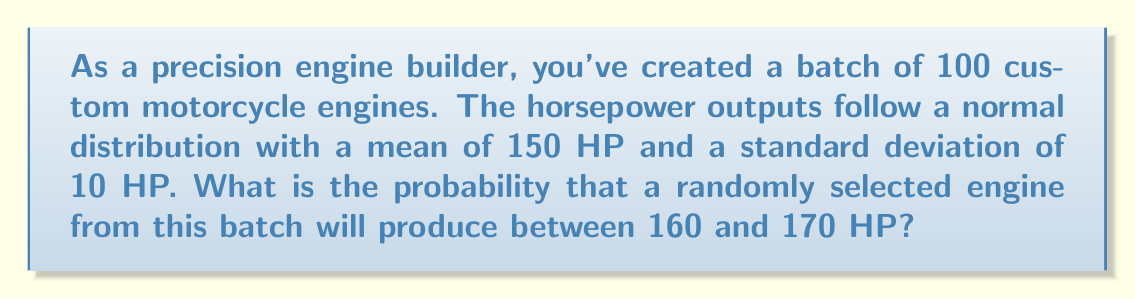Show me your answer to this math problem. To solve this problem, we'll use the properties of the normal distribution and the z-score formula.

Step 1: Identify the given information
- Mean (μ) = 150 HP
- Standard deviation (σ) = 10 HP
- We want the probability of an engine producing between 160 and 170 HP

Step 2: Calculate the z-scores for the lower and upper bounds
z-score formula: $z = \frac{x - μ}{σ}$

For 160 HP: $z_1 = \frac{160 - 150}{10} = 1$
For 170 HP: $z_2 = \frac{170 - 150}{10} = 2$

Step 3: Use the standard normal distribution table or a calculator to find the area under the curve between these z-scores

The probability is the area between z = 1 and z = 2 on the standard normal distribution.

$P(1 < z < 2) = P(z < 2) - P(z < 1)$

Using a standard normal table or calculator:
$P(z < 2) ≈ 0.9772$
$P(z < 1) ≈ 0.8413$

$P(1 < z < 2) = 0.9772 - 0.8413 = 0.1359$

Step 4: Convert the probability to a percentage
$0.1359 * 100\% = 13.59\%$
Answer: 13.59% 